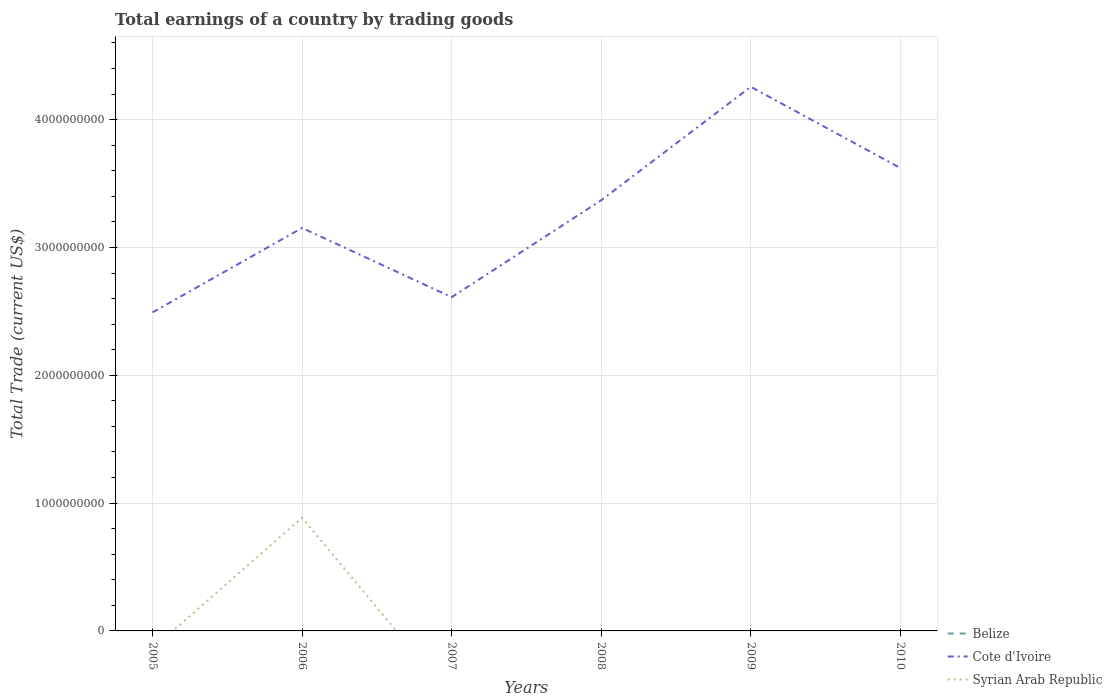Does the line corresponding to Syrian Arab Republic intersect with the line corresponding to Cote d'Ivoire?
Ensure brevity in your answer.  No. Across all years, what is the maximum total earnings in Cote d'Ivoire?
Provide a short and direct response. 2.49e+09. What is the total total earnings in Cote d'Ivoire in the graph?
Offer a very short reply. 5.42e+08. What is the difference between the highest and the second highest total earnings in Syrian Arab Republic?
Make the answer very short. 8.86e+08. How many lines are there?
Give a very brief answer. 2. What is the difference between two consecutive major ticks on the Y-axis?
Offer a terse response. 1.00e+09. Does the graph contain any zero values?
Provide a succinct answer. Yes. Does the graph contain grids?
Make the answer very short. Yes. Where does the legend appear in the graph?
Provide a short and direct response. Bottom right. How many legend labels are there?
Ensure brevity in your answer.  3. How are the legend labels stacked?
Offer a very short reply. Vertical. What is the title of the graph?
Give a very brief answer. Total earnings of a country by trading goods. What is the label or title of the Y-axis?
Ensure brevity in your answer.  Total Trade (current US$). What is the Total Trade (current US$) in Cote d'Ivoire in 2005?
Your answer should be very brief. 2.49e+09. What is the Total Trade (current US$) of Syrian Arab Republic in 2005?
Provide a succinct answer. 0. What is the Total Trade (current US$) in Cote d'Ivoire in 2006?
Your answer should be compact. 3.15e+09. What is the Total Trade (current US$) of Syrian Arab Republic in 2006?
Your response must be concise. 8.86e+08. What is the Total Trade (current US$) in Cote d'Ivoire in 2007?
Make the answer very short. 2.61e+09. What is the Total Trade (current US$) of Cote d'Ivoire in 2008?
Your answer should be very brief. 3.37e+09. What is the Total Trade (current US$) of Syrian Arab Republic in 2008?
Offer a terse response. 0. What is the Total Trade (current US$) in Belize in 2009?
Your answer should be very brief. 0. What is the Total Trade (current US$) of Cote d'Ivoire in 2009?
Offer a terse response. 4.26e+09. What is the Total Trade (current US$) of Cote d'Ivoire in 2010?
Your answer should be compact. 3.62e+09. What is the Total Trade (current US$) in Syrian Arab Republic in 2010?
Provide a succinct answer. 0. Across all years, what is the maximum Total Trade (current US$) of Cote d'Ivoire?
Keep it short and to the point. 4.26e+09. Across all years, what is the maximum Total Trade (current US$) of Syrian Arab Republic?
Ensure brevity in your answer.  8.86e+08. Across all years, what is the minimum Total Trade (current US$) of Cote d'Ivoire?
Provide a short and direct response. 2.49e+09. Across all years, what is the minimum Total Trade (current US$) in Syrian Arab Republic?
Offer a very short reply. 0. What is the total Total Trade (current US$) in Cote d'Ivoire in the graph?
Ensure brevity in your answer.  1.95e+1. What is the total Total Trade (current US$) of Syrian Arab Republic in the graph?
Offer a terse response. 8.86e+08. What is the difference between the Total Trade (current US$) in Cote d'Ivoire in 2005 and that in 2006?
Make the answer very short. -6.60e+08. What is the difference between the Total Trade (current US$) of Cote d'Ivoire in 2005 and that in 2007?
Keep it short and to the point. -1.19e+08. What is the difference between the Total Trade (current US$) of Cote d'Ivoire in 2005 and that in 2008?
Offer a very short reply. -8.77e+08. What is the difference between the Total Trade (current US$) in Cote d'Ivoire in 2005 and that in 2009?
Make the answer very short. -1.76e+09. What is the difference between the Total Trade (current US$) in Cote d'Ivoire in 2005 and that in 2010?
Provide a succinct answer. -1.13e+09. What is the difference between the Total Trade (current US$) in Cote d'Ivoire in 2006 and that in 2007?
Your answer should be compact. 5.42e+08. What is the difference between the Total Trade (current US$) in Cote d'Ivoire in 2006 and that in 2008?
Make the answer very short. -2.17e+08. What is the difference between the Total Trade (current US$) of Cote d'Ivoire in 2006 and that in 2009?
Your response must be concise. -1.10e+09. What is the difference between the Total Trade (current US$) of Cote d'Ivoire in 2006 and that in 2010?
Make the answer very short. -4.69e+08. What is the difference between the Total Trade (current US$) in Cote d'Ivoire in 2007 and that in 2008?
Ensure brevity in your answer.  -7.58e+08. What is the difference between the Total Trade (current US$) of Cote d'Ivoire in 2007 and that in 2009?
Make the answer very short. -1.65e+09. What is the difference between the Total Trade (current US$) of Cote d'Ivoire in 2007 and that in 2010?
Offer a very short reply. -1.01e+09. What is the difference between the Total Trade (current US$) of Cote d'Ivoire in 2008 and that in 2009?
Your response must be concise. -8.88e+08. What is the difference between the Total Trade (current US$) in Cote d'Ivoire in 2008 and that in 2010?
Make the answer very short. -2.52e+08. What is the difference between the Total Trade (current US$) of Cote d'Ivoire in 2009 and that in 2010?
Your answer should be compact. 6.35e+08. What is the difference between the Total Trade (current US$) of Cote d'Ivoire in 2005 and the Total Trade (current US$) of Syrian Arab Republic in 2006?
Offer a very short reply. 1.61e+09. What is the average Total Trade (current US$) of Cote d'Ivoire per year?
Your answer should be compact. 3.25e+09. What is the average Total Trade (current US$) of Syrian Arab Republic per year?
Offer a very short reply. 1.48e+08. In the year 2006, what is the difference between the Total Trade (current US$) of Cote d'Ivoire and Total Trade (current US$) of Syrian Arab Republic?
Your answer should be compact. 2.27e+09. What is the ratio of the Total Trade (current US$) of Cote d'Ivoire in 2005 to that in 2006?
Provide a short and direct response. 0.79. What is the ratio of the Total Trade (current US$) in Cote d'Ivoire in 2005 to that in 2007?
Your answer should be compact. 0.95. What is the ratio of the Total Trade (current US$) of Cote d'Ivoire in 2005 to that in 2008?
Ensure brevity in your answer.  0.74. What is the ratio of the Total Trade (current US$) of Cote d'Ivoire in 2005 to that in 2009?
Your response must be concise. 0.59. What is the ratio of the Total Trade (current US$) of Cote d'Ivoire in 2005 to that in 2010?
Provide a succinct answer. 0.69. What is the ratio of the Total Trade (current US$) of Cote d'Ivoire in 2006 to that in 2007?
Make the answer very short. 1.21. What is the ratio of the Total Trade (current US$) of Cote d'Ivoire in 2006 to that in 2008?
Provide a succinct answer. 0.94. What is the ratio of the Total Trade (current US$) of Cote d'Ivoire in 2006 to that in 2009?
Your response must be concise. 0.74. What is the ratio of the Total Trade (current US$) in Cote d'Ivoire in 2006 to that in 2010?
Ensure brevity in your answer.  0.87. What is the ratio of the Total Trade (current US$) of Cote d'Ivoire in 2007 to that in 2008?
Give a very brief answer. 0.78. What is the ratio of the Total Trade (current US$) in Cote d'Ivoire in 2007 to that in 2009?
Make the answer very short. 0.61. What is the ratio of the Total Trade (current US$) of Cote d'Ivoire in 2007 to that in 2010?
Keep it short and to the point. 0.72. What is the ratio of the Total Trade (current US$) in Cote d'Ivoire in 2008 to that in 2009?
Offer a very short reply. 0.79. What is the ratio of the Total Trade (current US$) in Cote d'Ivoire in 2008 to that in 2010?
Keep it short and to the point. 0.93. What is the ratio of the Total Trade (current US$) in Cote d'Ivoire in 2009 to that in 2010?
Your answer should be very brief. 1.18. What is the difference between the highest and the second highest Total Trade (current US$) of Cote d'Ivoire?
Your response must be concise. 6.35e+08. What is the difference between the highest and the lowest Total Trade (current US$) in Cote d'Ivoire?
Provide a succinct answer. 1.76e+09. What is the difference between the highest and the lowest Total Trade (current US$) of Syrian Arab Republic?
Offer a very short reply. 8.86e+08. 